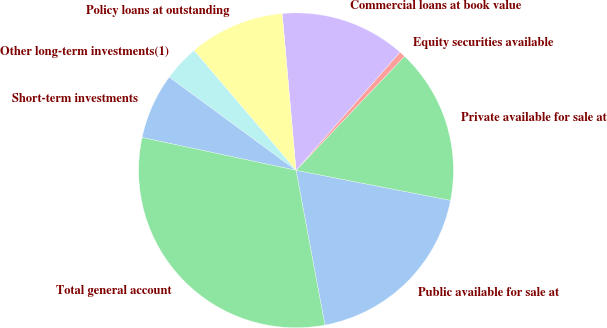Convert chart. <chart><loc_0><loc_0><loc_500><loc_500><pie_chart><fcel>Public available for sale at<fcel>Private available for sale at<fcel>Equity securities available<fcel>Commercial loans at book value<fcel>Policy loans at outstanding<fcel>Other long-term investments(1)<fcel>Short-term investments<fcel>Total general account<nl><fcel>19.01%<fcel>15.95%<fcel>0.63%<fcel>12.88%<fcel>9.82%<fcel>3.69%<fcel>6.75%<fcel>31.27%<nl></chart> 